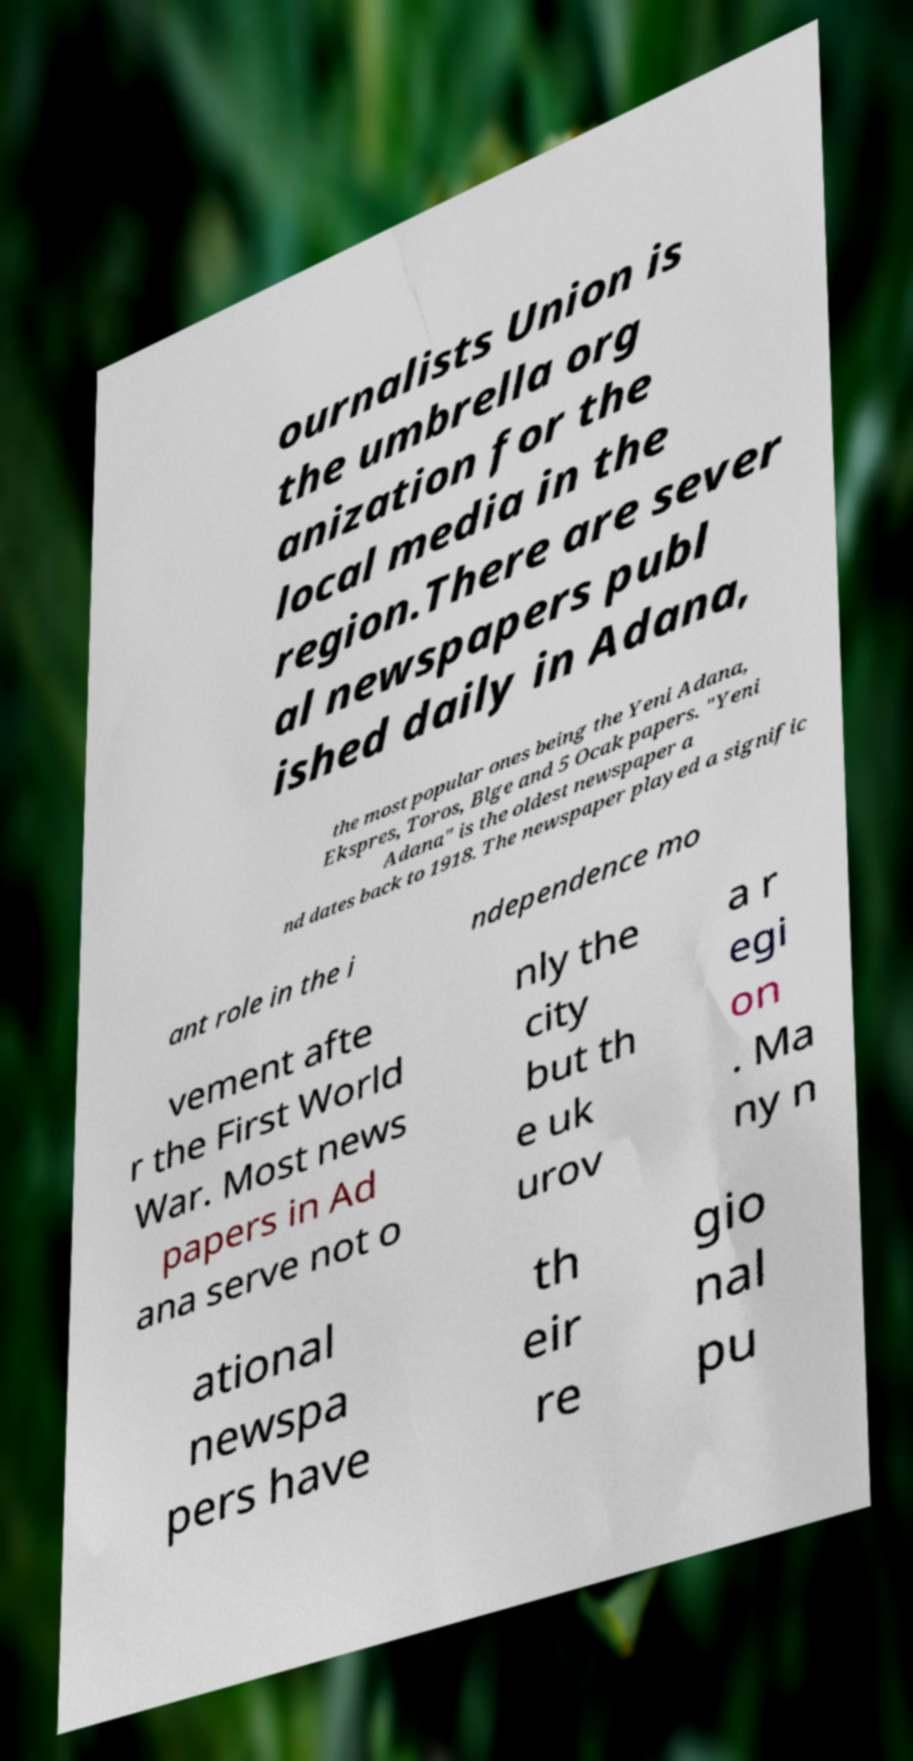I need the written content from this picture converted into text. Can you do that? ournalists Union is the umbrella org anization for the local media in the region.There are sever al newspapers publ ished daily in Adana, the most popular ones being the Yeni Adana, Ekspres, Toros, Blge and 5 Ocak papers. "Yeni Adana" is the oldest newspaper a nd dates back to 1918. The newspaper played a signific ant role in the i ndependence mo vement afte r the First World War. Most news papers in Ad ana serve not o nly the city but th e uk urov a r egi on . Ma ny n ational newspa pers have th eir re gio nal pu 